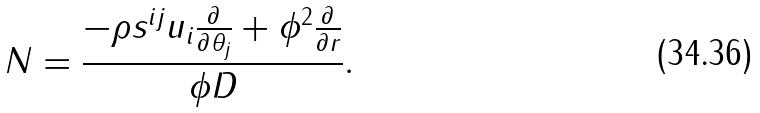Convert formula to latex. <formula><loc_0><loc_0><loc_500><loc_500>N = \frac { - \rho s ^ { i j } u _ { i } \frac { \partial } { \partial \theta _ { j } } + \phi ^ { 2 } \frac { \partial } { \partial r } } { \phi D } .</formula> 